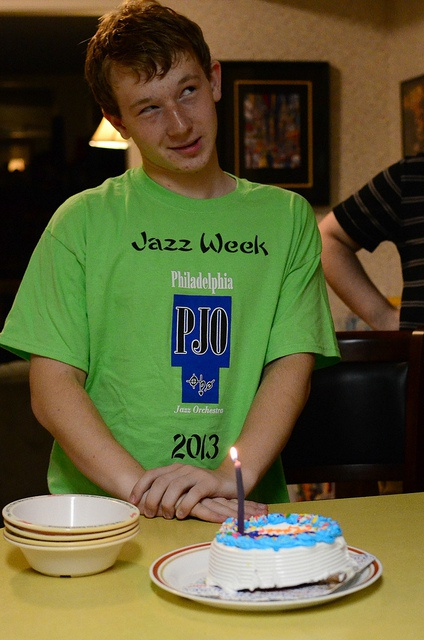Describe the objects in this image and their specific colors. I can see people in tan, green, black, and gray tones, dining table in tan and olive tones, chair in tan, black, maroon, and gray tones, people in tan, black, maroon, and brown tones, and cake in tan, lightgray, lightblue, and darkgray tones in this image. 